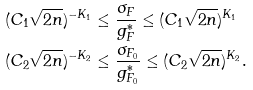<formula> <loc_0><loc_0><loc_500><loc_500>( C _ { 1 } \sqrt { 2 n } ) ^ { - K _ { 1 } } & \leq \frac { \sigma _ { F } } { g _ { F } ^ { \ast } } \leq ( C _ { 1 } \sqrt { 2 n } ) ^ { K _ { 1 } } \\ ( C _ { 2 } \sqrt { 2 n } ) ^ { - K _ { 2 } } & \leq \frac { \sigma _ { F _ { 0 } } } { g _ { F _ { 0 } } ^ { \ast } } \leq ( C _ { 2 } \sqrt { 2 n } ) ^ { K _ { 2 } } .</formula> 